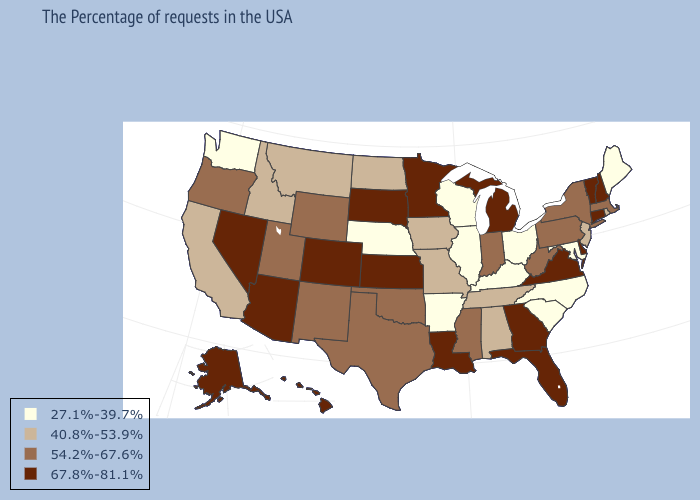Among the states that border Missouri , does Oklahoma have the highest value?
Answer briefly. No. Does Mississippi have a lower value than Alabama?
Write a very short answer. No. Which states have the lowest value in the USA?
Write a very short answer. Maine, Maryland, North Carolina, South Carolina, Ohio, Kentucky, Wisconsin, Illinois, Arkansas, Nebraska, Washington. Does Michigan have the highest value in the MidWest?
Quick response, please. Yes. How many symbols are there in the legend?
Keep it brief. 4. What is the value of Kansas?
Give a very brief answer. 67.8%-81.1%. Name the states that have a value in the range 27.1%-39.7%?
Short answer required. Maine, Maryland, North Carolina, South Carolina, Ohio, Kentucky, Wisconsin, Illinois, Arkansas, Nebraska, Washington. Which states hav the highest value in the Northeast?
Short answer required. New Hampshire, Vermont, Connecticut. Does Kentucky have the highest value in the USA?
Be succinct. No. Name the states that have a value in the range 54.2%-67.6%?
Short answer required. Massachusetts, New York, Pennsylvania, West Virginia, Indiana, Mississippi, Oklahoma, Texas, Wyoming, New Mexico, Utah, Oregon. Among the states that border New Hampshire , does Vermont have the lowest value?
Concise answer only. No. Among the states that border Maine , which have the highest value?
Give a very brief answer. New Hampshire. Is the legend a continuous bar?
Give a very brief answer. No. What is the value of Michigan?
Short answer required. 67.8%-81.1%. Does Maryland have the lowest value in the USA?
Keep it brief. Yes. 